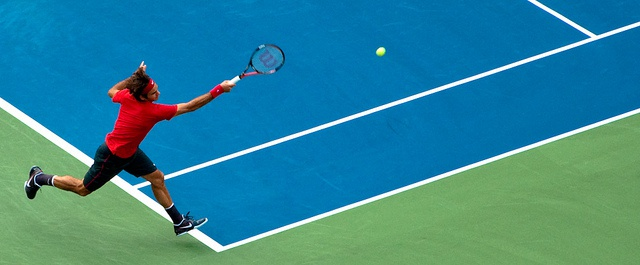Describe the objects in this image and their specific colors. I can see people in teal, black, maroon, brown, and red tones, tennis racket in teal, gray, and blue tones, and sports ball in teal, khaki, lightyellow, lime, and lightgreen tones in this image. 